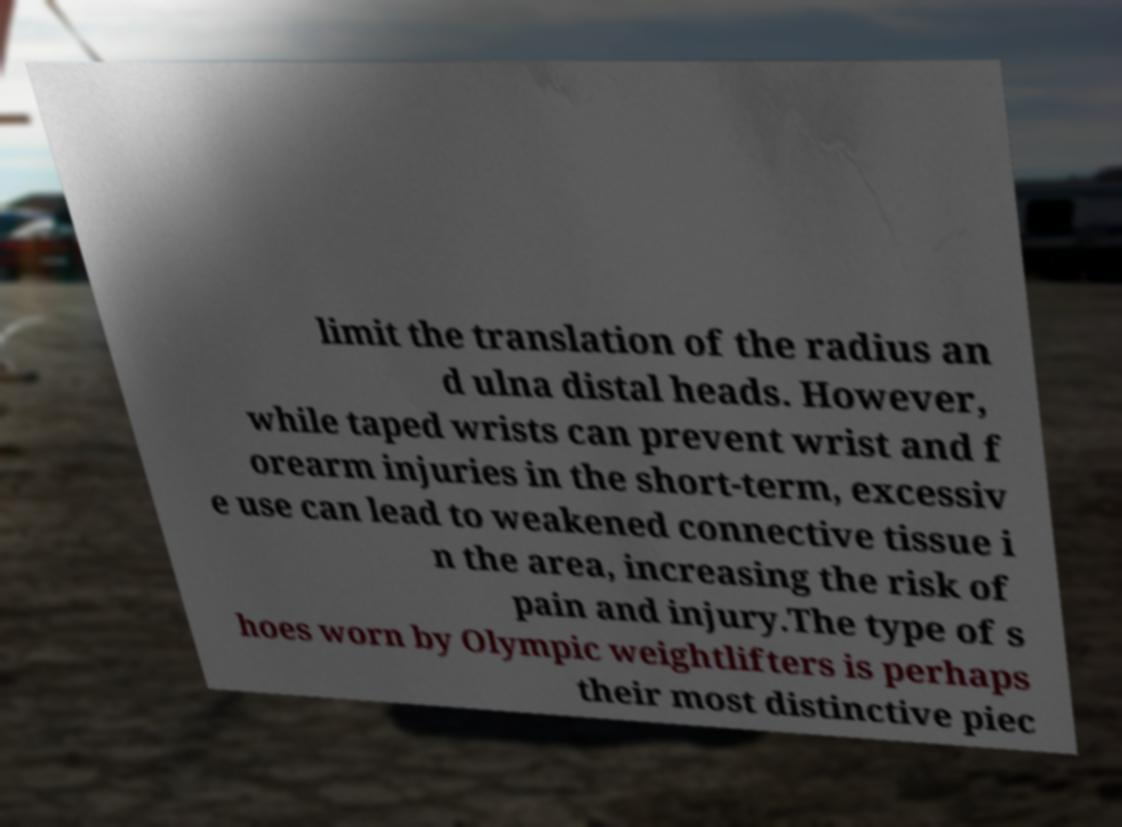Could you assist in decoding the text presented in this image and type it out clearly? limit the translation of the radius an d ulna distal heads. However, while taped wrists can prevent wrist and f orearm injuries in the short-term, excessiv e use can lead to weakened connective tissue i n the area, increasing the risk of pain and injury.The type of s hoes worn by Olympic weightlifters is perhaps their most distinctive piec 